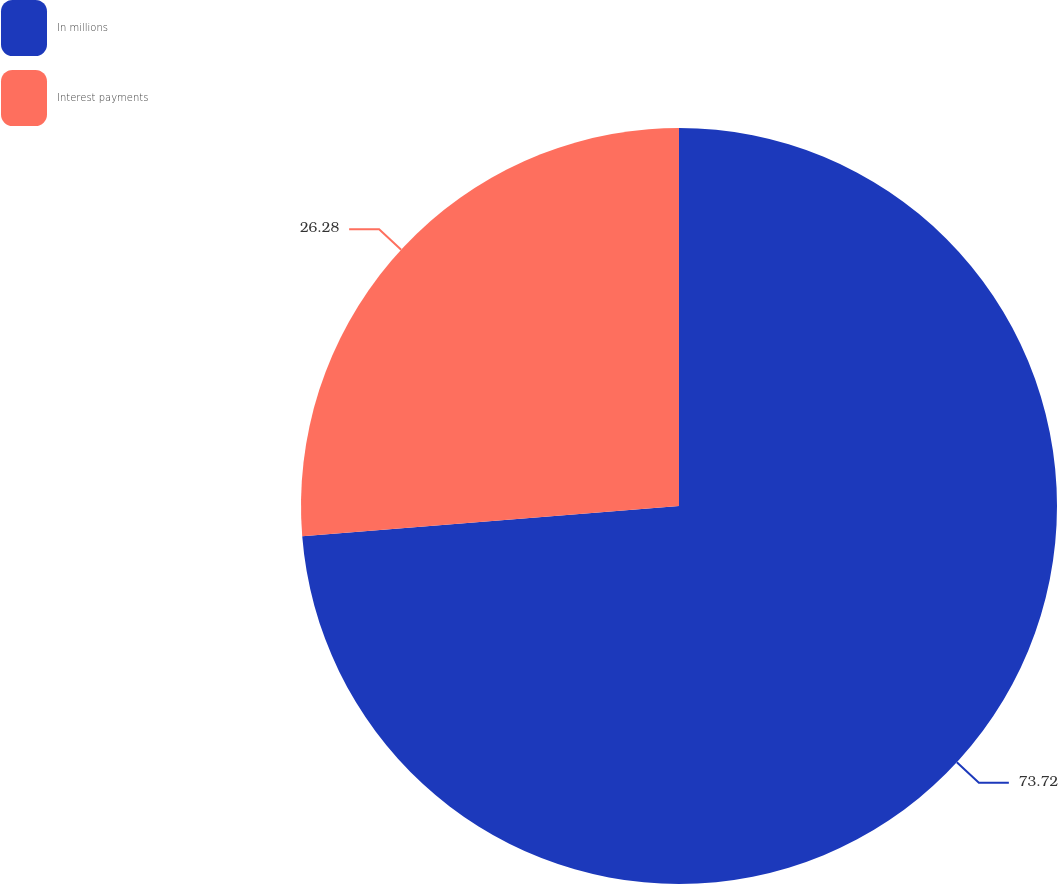Convert chart to OTSL. <chart><loc_0><loc_0><loc_500><loc_500><pie_chart><fcel>In millions<fcel>Interest payments<nl><fcel>73.72%<fcel>26.28%<nl></chart> 